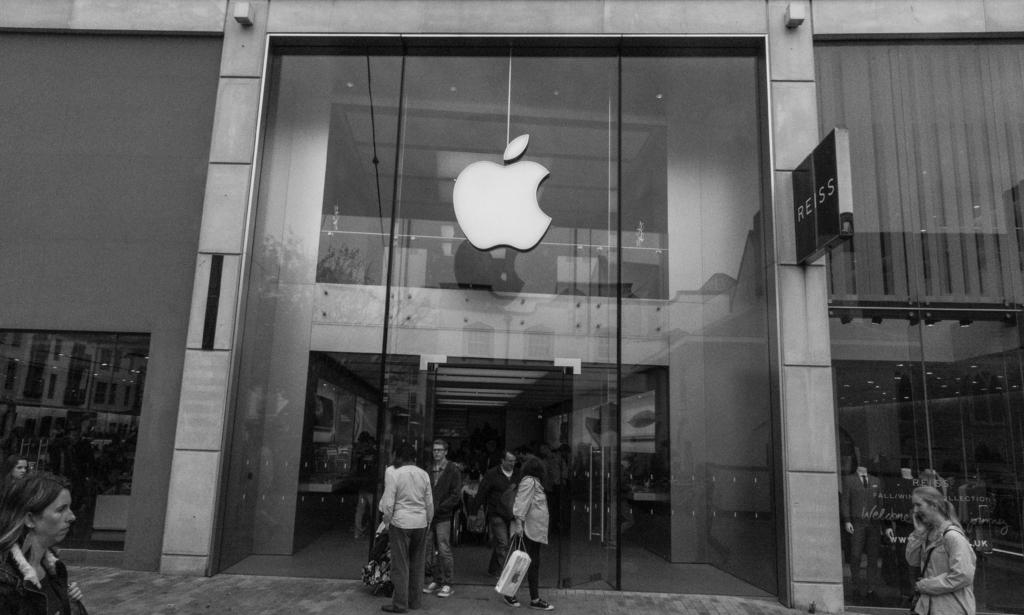What type of structure is visible in the image? There is a building in the image. What feature can be seen on the building? The building has mirrors. Are there any people inside the building? Yes, there are persons standing on the floor inside the building. What other objects can be found inside the building? There are mannequins inside the building. What type of science experiment is being conducted by the persons inside the building? There is no indication of a science experiment being conducted in the image. 